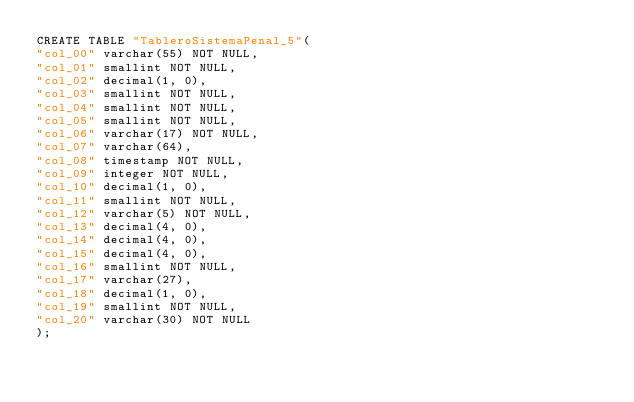Convert code to text. <code><loc_0><loc_0><loc_500><loc_500><_SQL_>CREATE TABLE "TableroSistemaPenal_5"(
"col_00" varchar(55) NOT NULL,
"col_01" smallint NOT NULL,
"col_02" decimal(1, 0),
"col_03" smallint NOT NULL,
"col_04" smallint NOT NULL,
"col_05" smallint NOT NULL,
"col_06" varchar(17) NOT NULL,
"col_07" varchar(64),
"col_08" timestamp NOT NULL,
"col_09" integer NOT NULL,
"col_10" decimal(1, 0),
"col_11" smallint NOT NULL,
"col_12" varchar(5) NOT NULL,
"col_13" decimal(4, 0),
"col_14" decimal(4, 0),
"col_15" decimal(4, 0),
"col_16" smallint NOT NULL,
"col_17" varchar(27),
"col_18" decimal(1, 0),
"col_19" smallint NOT NULL,
"col_20" varchar(30) NOT NULL
);
</code> 